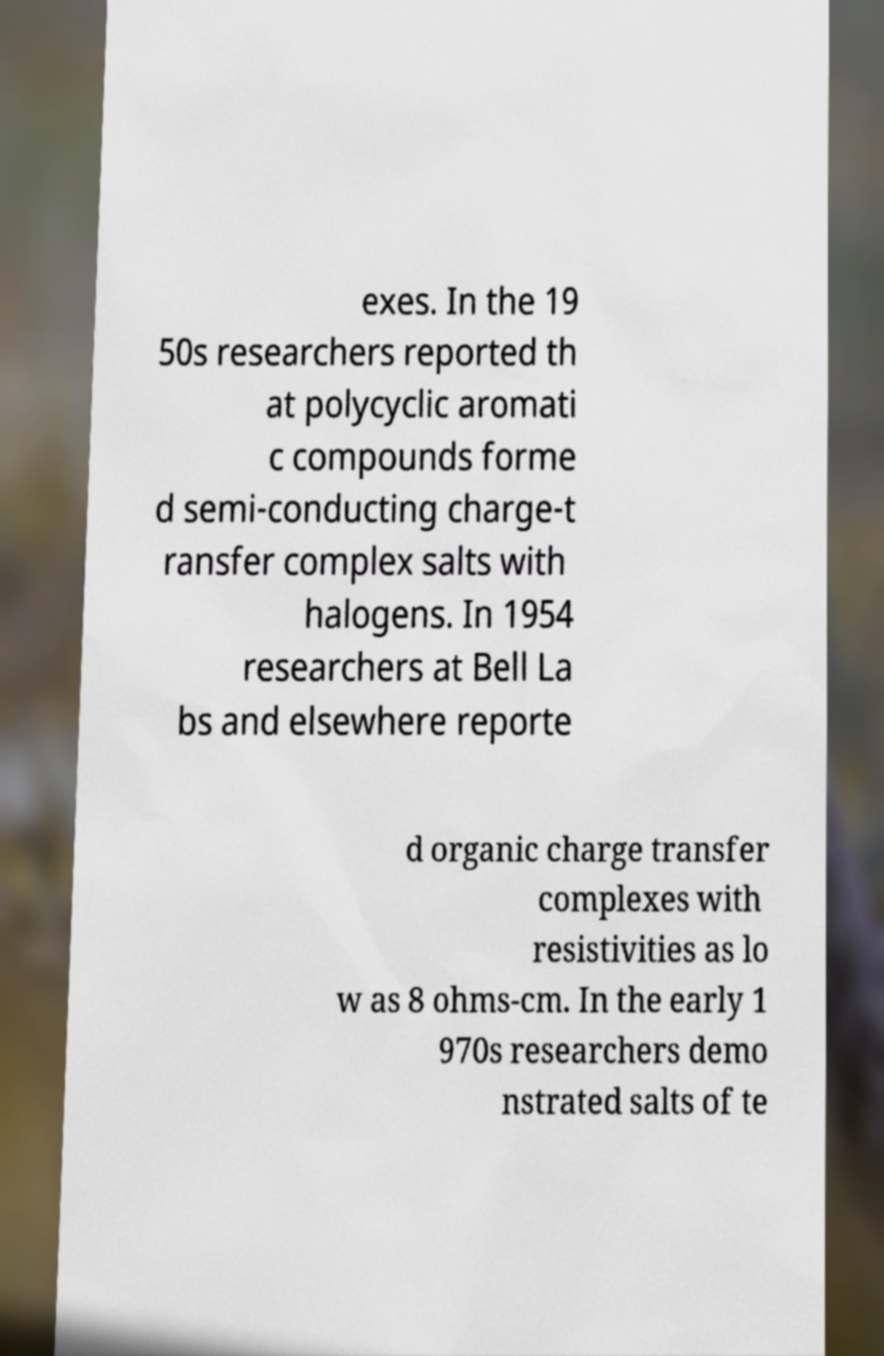I need the written content from this picture converted into text. Can you do that? exes. In the 19 50s researchers reported th at polycyclic aromati c compounds forme d semi-conducting charge-t ransfer complex salts with halogens. In 1954 researchers at Bell La bs and elsewhere reporte d organic charge transfer complexes with resistivities as lo w as 8 ohms-cm. In the early 1 970s researchers demo nstrated salts of te 